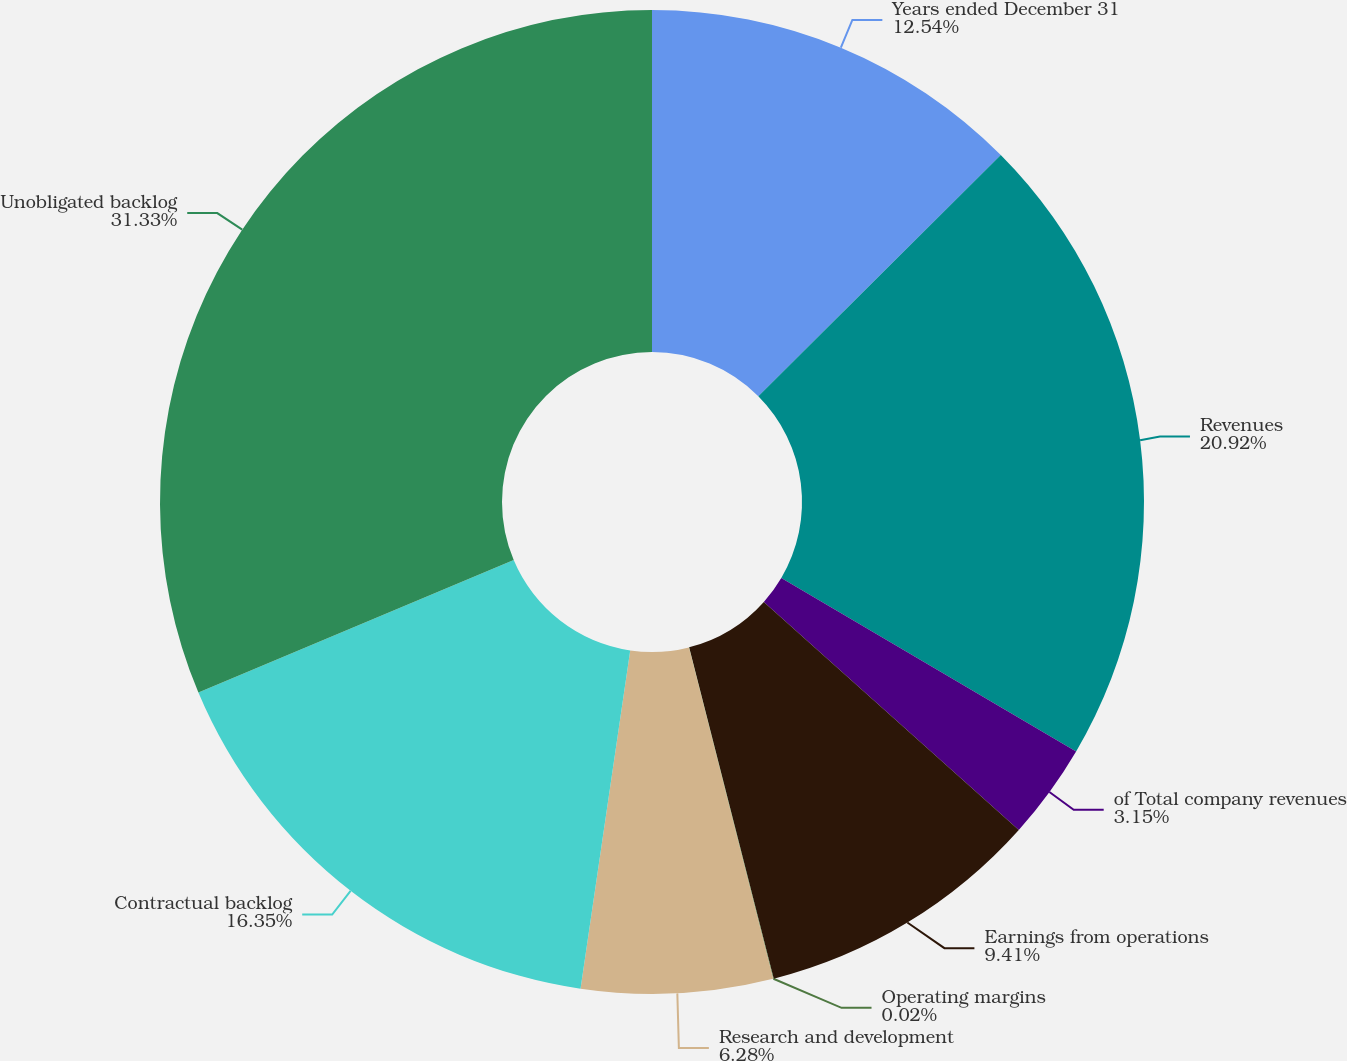<chart> <loc_0><loc_0><loc_500><loc_500><pie_chart><fcel>Years ended December 31<fcel>Revenues<fcel>of Total company revenues<fcel>Earnings from operations<fcel>Operating margins<fcel>Research and development<fcel>Contractual backlog<fcel>Unobligated backlog<nl><fcel>12.54%<fcel>20.92%<fcel>3.15%<fcel>9.41%<fcel>0.02%<fcel>6.28%<fcel>16.35%<fcel>31.33%<nl></chart> 